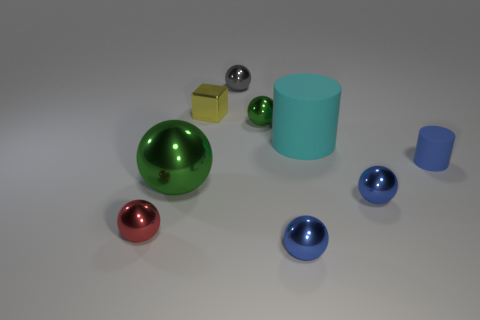The cyan cylinder is what size?
Ensure brevity in your answer.  Large. What number of tiny cubes are the same color as the tiny matte thing?
Ensure brevity in your answer.  0. Are there any tiny rubber objects that are to the left of the sphere that is behind the green metallic sphere that is right of the cube?
Your answer should be very brief. No. What shape is the gray metal object that is the same size as the blue matte thing?
Make the answer very short. Sphere. How many tiny things are green objects or blue cylinders?
Ensure brevity in your answer.  2. The small object that is made of the same material as the big cyan cylinder is what color?
Your answer should be compact. Blue. Do the small blue object behind the large shiny ball and the green metal object that is in front of the big cyan matte cylinder have the same shape?
Offer a terse response. No. How many rubber things are small spheres or blue balls?
Your answer should be compact. 0. There is a tiny object that is the same color as the big shiny ball; what material is it?
Provide a succinct answer. Metal. Is there anything else that is the same shape as the yellow thing?
Your response must be concise. No. 